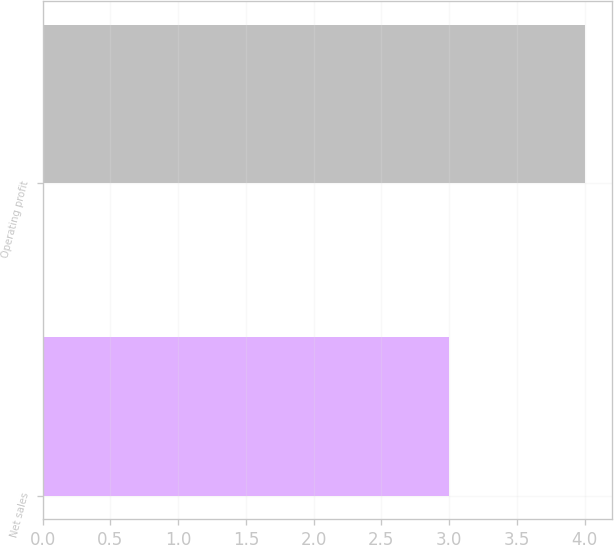Convert chart. <chart><loc_0><loc_0><loc_500><loc_500><bar_chart><fcel>Net sales<fcel>Operating profit<nl><fcel>3<fcel>4<nl></chart> 